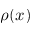<formula> <loc_0><loc_0><loc_500><loc_500>\rho ( x )</formula> 